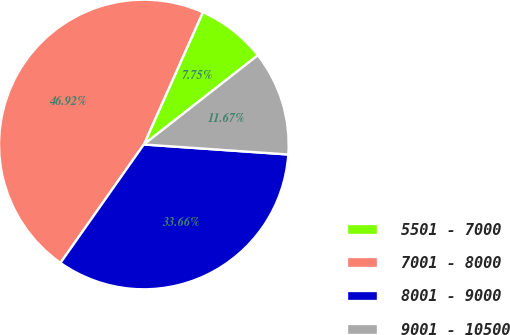Convert chart. <chart><loc_0><loc_0><loc_500><loc_500><pie_chart><fcel>5501 - 7000<fcel>7001 - 8000<fcel>8001 - 9000<fcel>9001 - 10500<nl><fcel>7.75%<fcel>46.92%<fcel>33.66%<fcel>11.67%<nl></chart> 